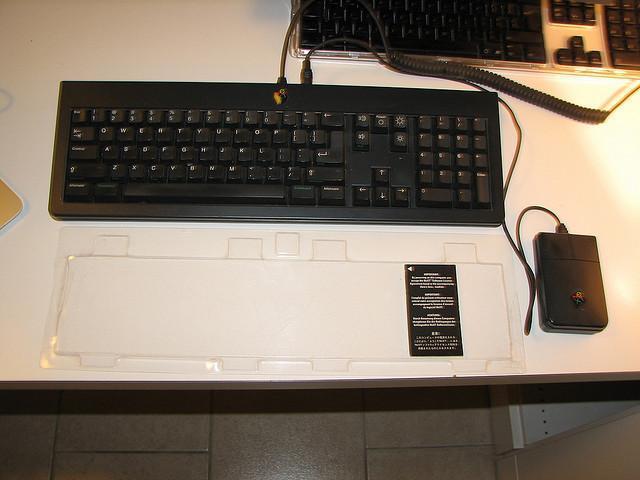How many keyboards can you see?
Give a very brief answer. 2. 